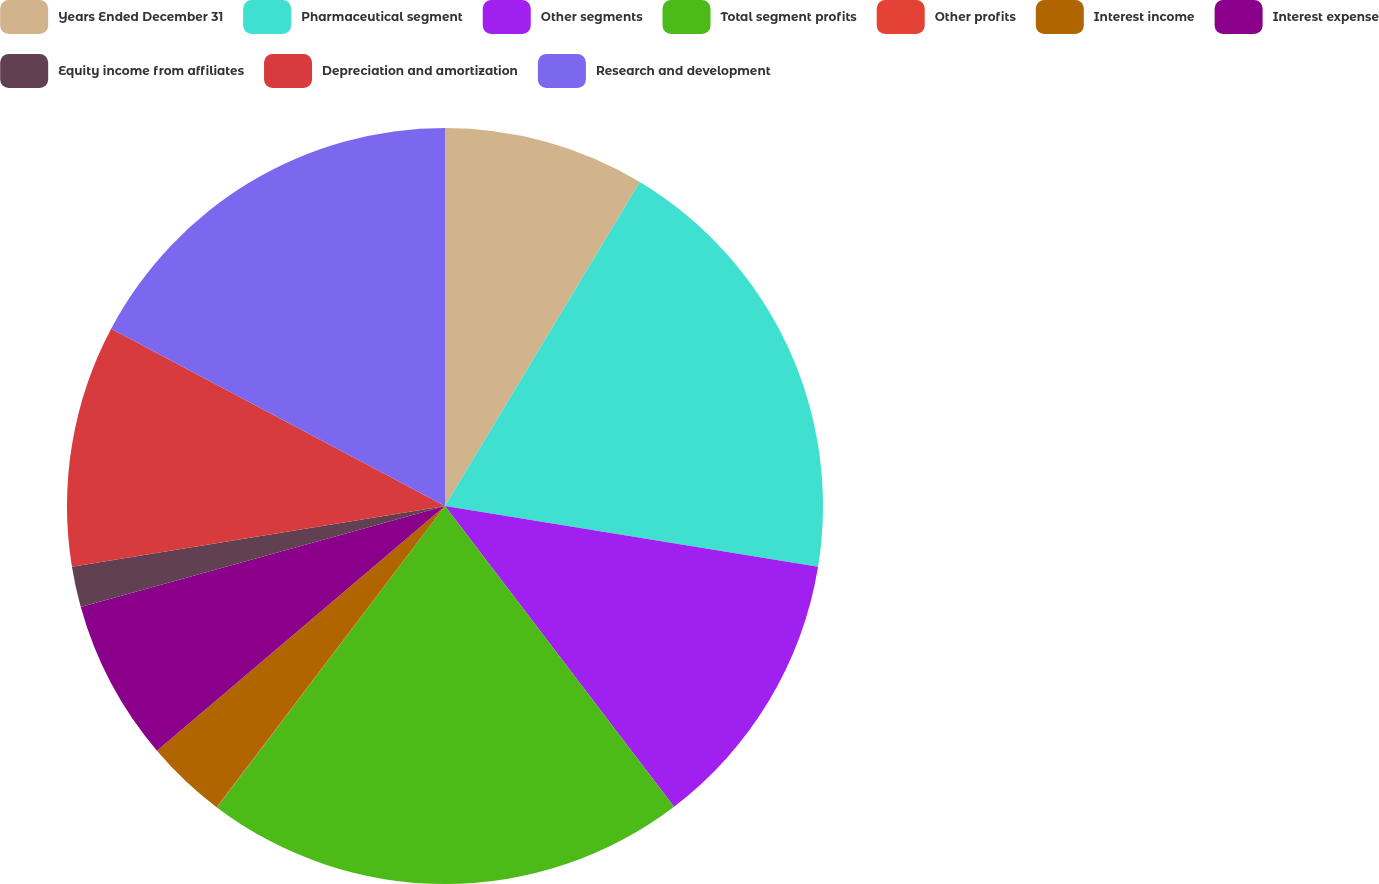<chart> <loc_0><loc_0><loc_500><loc_500><pie_chart><fcel>Years Ended December 31<fcel>Pharmaceutical segment<fcel>Other segments<fcel>Total segment profits<fcel>Other profits<fcel>Interest income<fcel>Interest expense<fcel>Equity income from affiliates<fcel>Depreciation and amortization<fcel>Research and development<nl><fcel>8.62%<fcel>18.95%<fcel>12.07%<fcel>20.67%<fcel>0.02%<fcel>3.46%<fcel>6.9%<fcel>1.74%<fcel>10.34%<fcel>17.23%<nl></chart> 